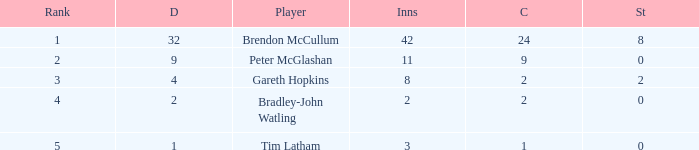How many innings contained 2 catches and 0 stumpings in total? 1.0. 